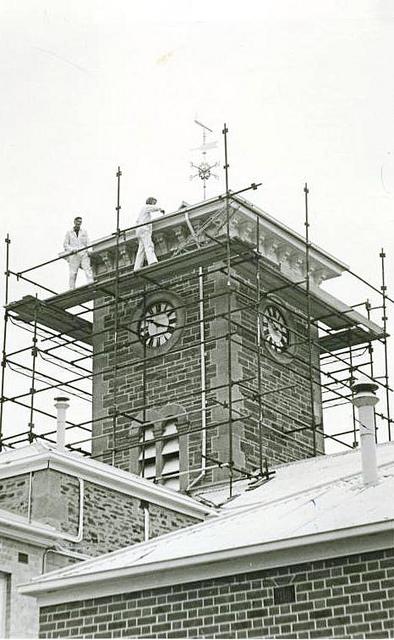Are the remodeling the building?
Concise answer only. Yes. How many pipes are in the picture?
Be succinct. 50. What is the building built with?
Concise answer only. Bricks. 